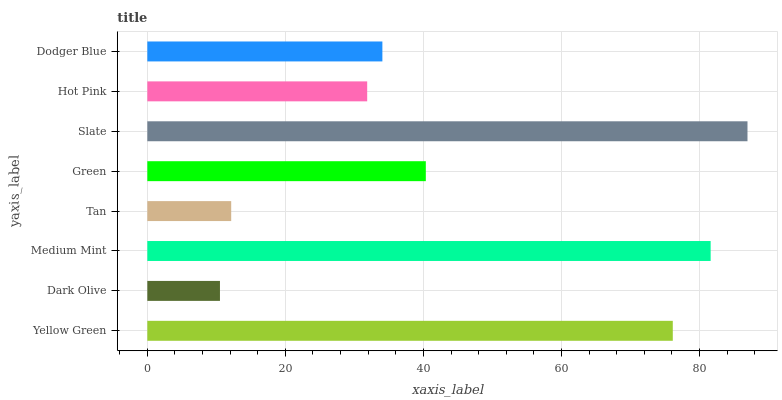Is Dark Olive the minimum?
Answer yes or no. Yes. Is Slate the maximum?
Answer yes or no. Yes. Is Medium Mint the minimum?
Answer yes or no. No. Is Medium Mint the maximum?
Answer yes or no. No. Is Medium Mint greater than Dark Olive?
Answer yes or no. Yes. Is Dark Olive less than Medium Mint?
Answer yes or no. Yes. Is Dark Olive greater than Medium Mint?
Answer yes or no. No. Is Medium Mint less than Dark Olive?
Answer yes or no. No. Is Green the high median?
Answer yes or no. Yes. Is Dodger Blue the low median?
Answer yes or no. Yes. Is Dodger Blue the high median?
Answer yes or no. No. Is Dark Olive the low median?
Answer yes or no. No. 